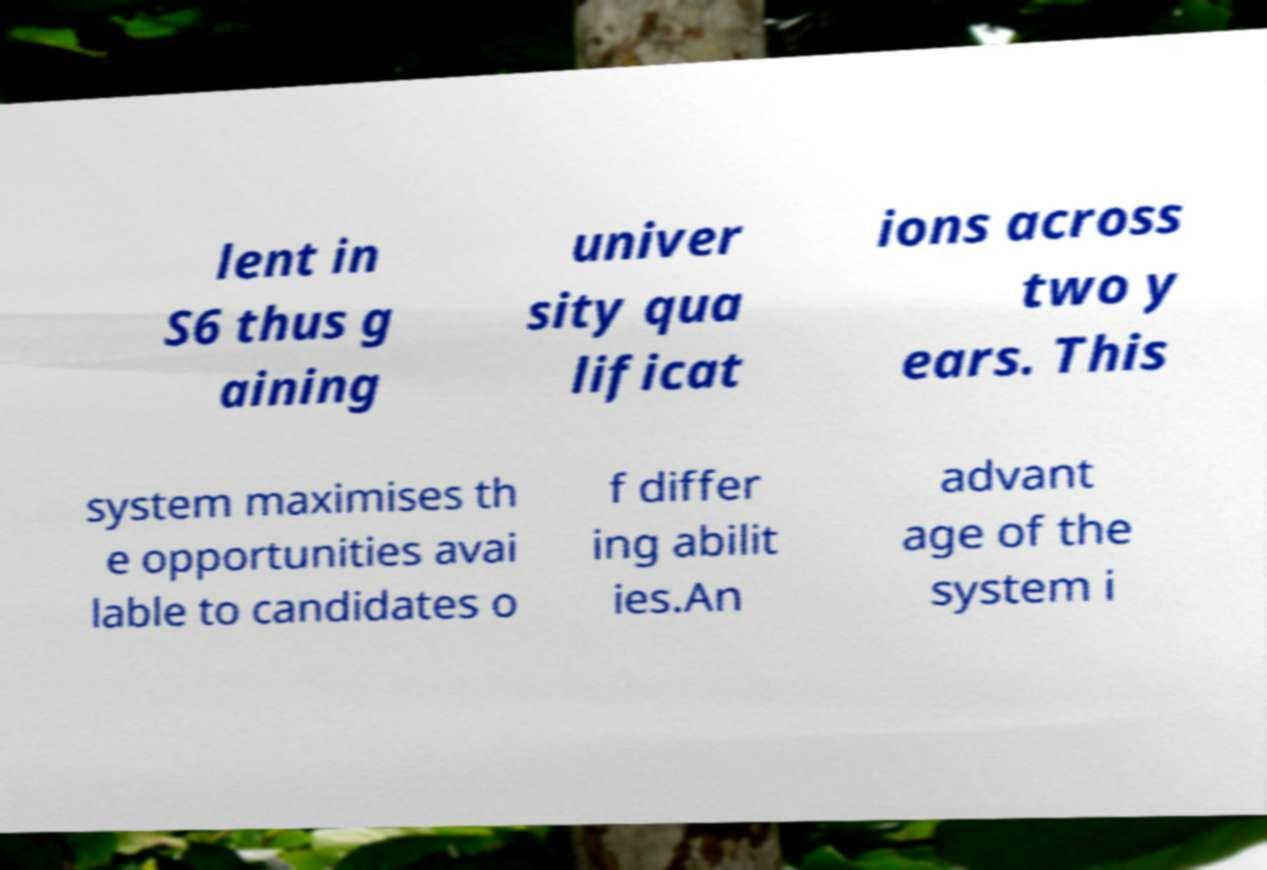Could you assist in decoding the text presented in this image and type it out clearly? lent in S6 thus g aining univer sity qua lificat ions across two y ears. This system maximises th e opportunities avai lable to candidates o f differ ing abilit ies.An advant age of the system i 